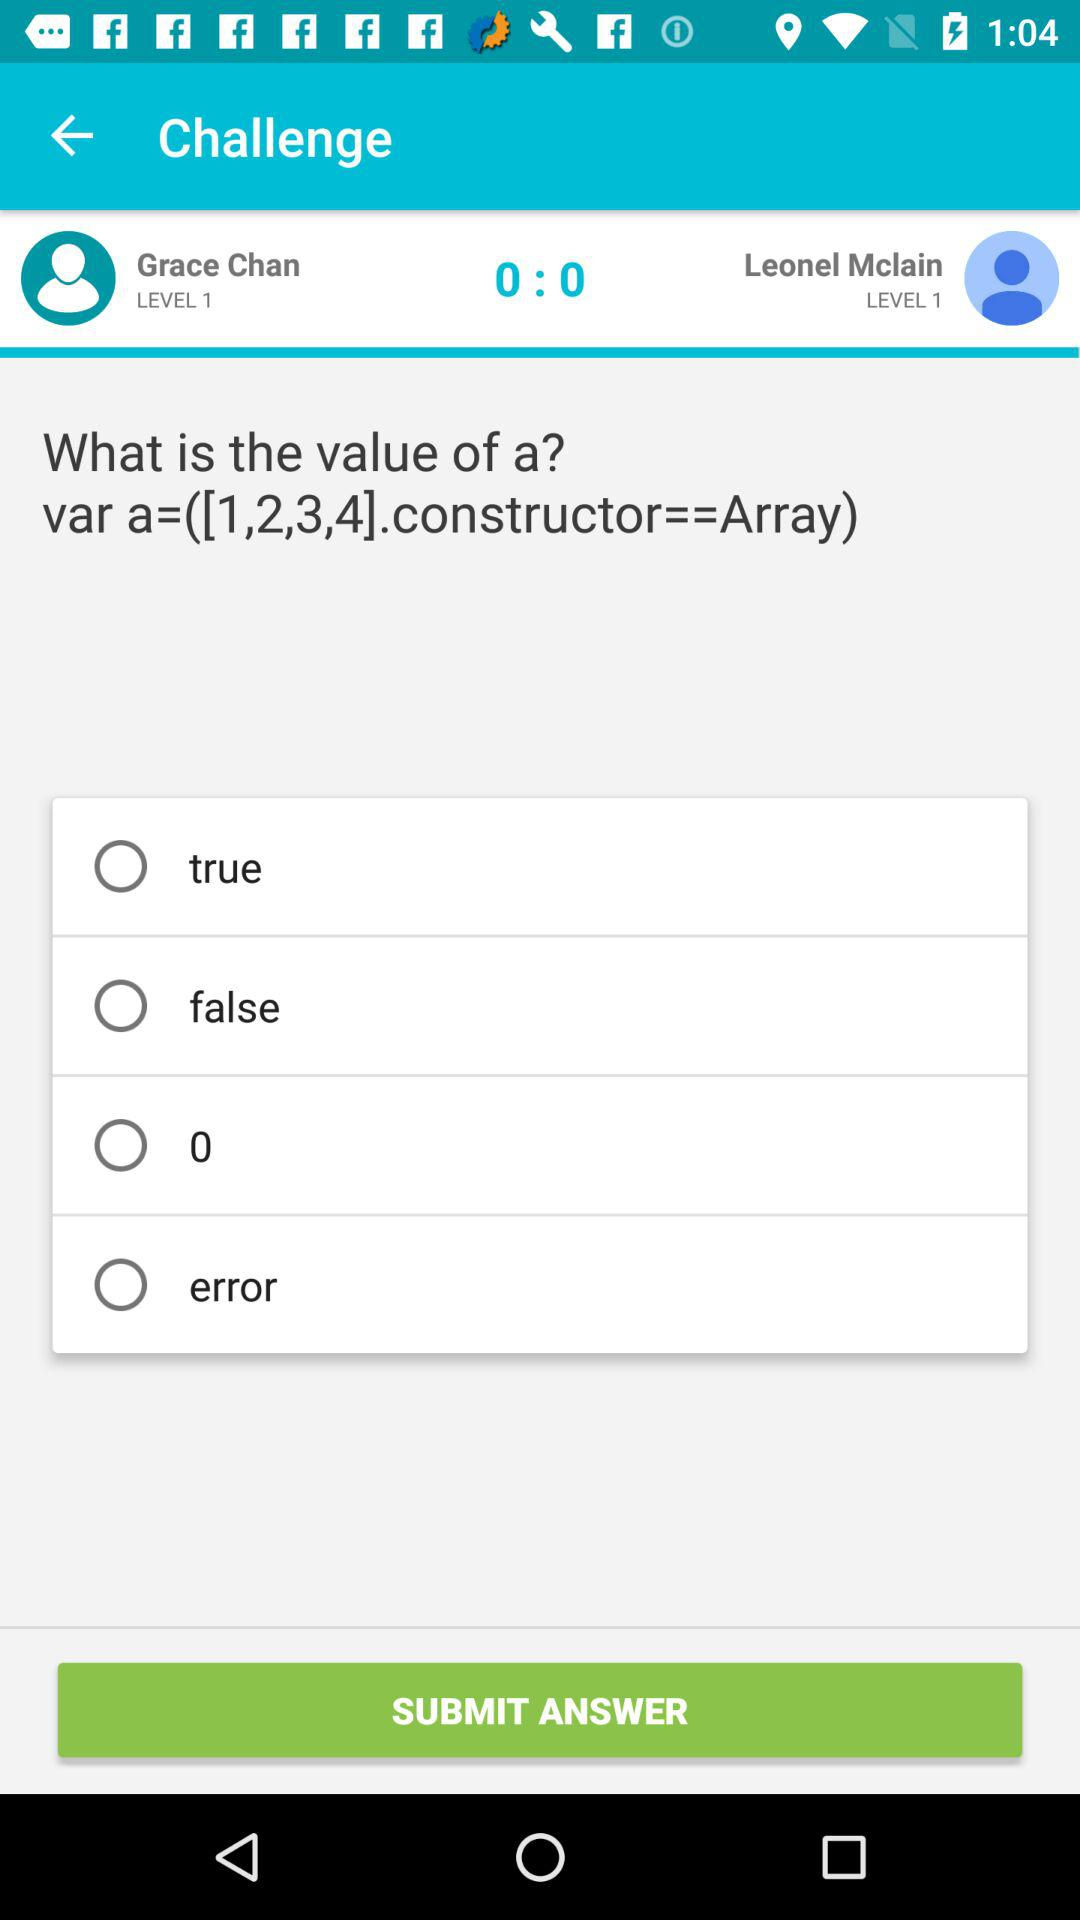What is the score? The score is 0:0. 